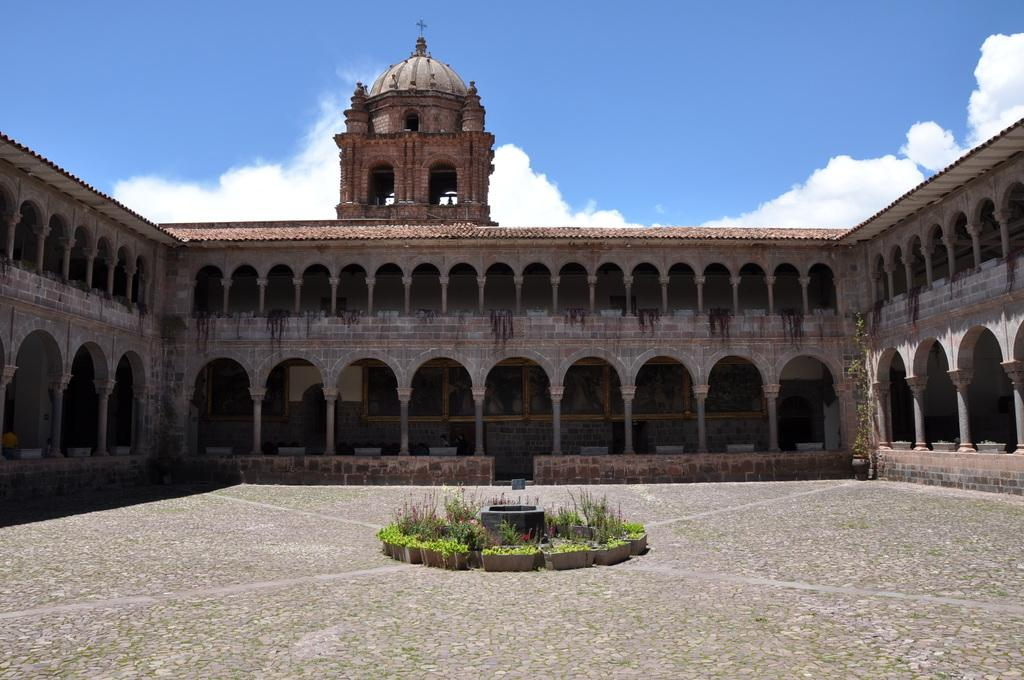What type of structure is visible in the image? There is a building in the image. What can be seen on the wall of the building? There are boards on the wall in the image. What is located in front of the building? There are plants in front of the building in the image. What is visible in the background of the image? There are clouds and a blue sky visible in the background of the image. How many snails can be seen crawling on the building in the image? There are no snails visible in the image; it only features a building, boards on the wall, plants, clouds, and a blue sky. What type of cannon is present on the roof of the building in the image? There is no cannon present on the roof of the building in the image. 